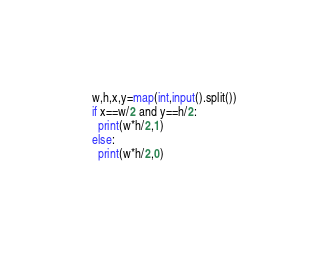Convert code to text. <code><loc_0><loc_0><loc_500><loc_500><_Python_>w,h,x,y=map(int,input().split())
if x==w/2 and y==h/2:
  print(w*h/2,1)
else:
  print(w*h/2,0)</code> 